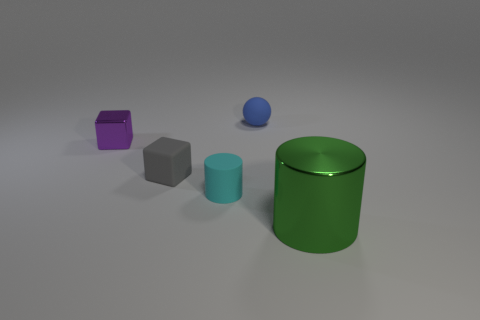Is there anything else that has the same shape as the blue rubber object?
Ensure brevity in your answer.  No. What is the color of the other object that is the same shape as the tiny purple object?
Provide a short and direct response. Gray. There is a metal thing that is behind the large green thing; what is its shape?
Provide a short and direct response. Cube. There is a gray cube; are there any purple objects behind it?
Your answer should be compact. Yes. Is there any other thing that is the same size as the metallic cylinder?
Ensure brevity in your answer.  No. There is a tiny block that is the same material as the big green object; what is its color?
Provide a succinct answer. Purple. How many cubes are green objects or small blue rubber objects?
Give a very brief answer. 0. Are there an equal number of small gray rubber cubes behind the purple metallic thing and big green cubes?
Provide a short and direct response. Yes. There is a cylinder right of the small matte thing that is on the right side of the cylinder to the left of the big shiny cylinder; what is it made of?
Offer a terse response. Metal. What number of things are small things that are behind the metallic block or blue matte objects?
Ensure brevity in your answer.  1. 